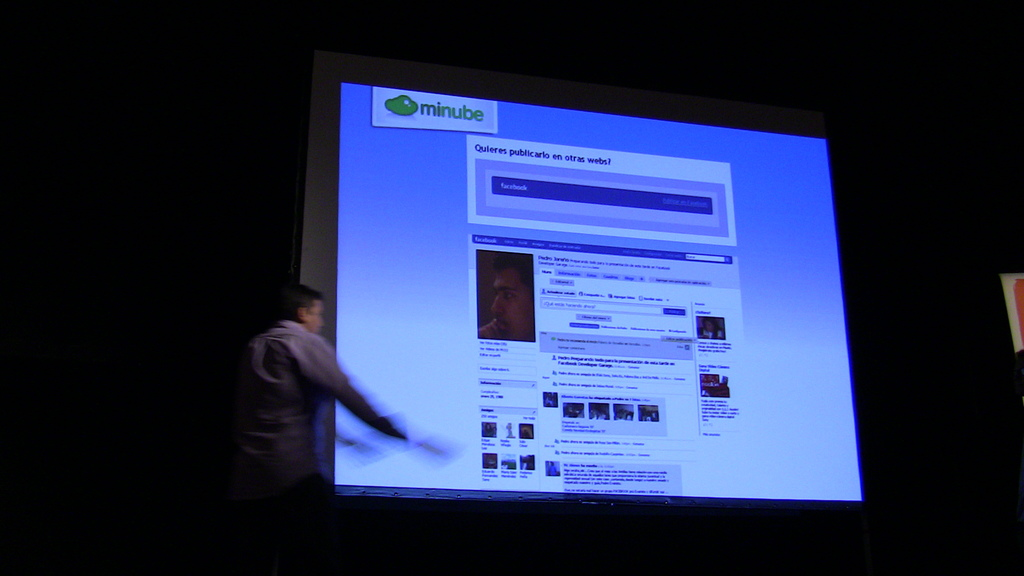What is the topic of the presentation shown in the image? The presentation appears to be about the 'minube' travel platform, focusing on how to utilize its features effectively. Are there any specific features visible on the screen that provide more insight about the presentation? Yes, the screen displays various travel destinations and user reviews, suggesting the presentation might be discussing how to navigate and make the best use of these features for planning trips. 